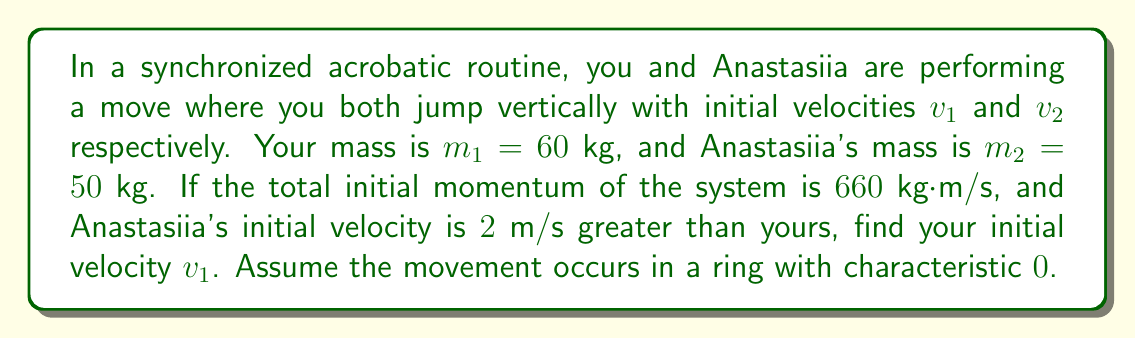Can you answer this question? Let's approach this step-by-step using the principles of momentum conservation and ring theory:

1) In a ring of characteristic 0, we can use standard algebraic operations. The total momentum of the system is given by:

   $$p_{total} = m_1v_1 + m_2v_2 = 660$$

2) We're told that Anastasiia's velocity is 2 m/s greater than yours:

   $$v_2 = v_1 + 2$$

3) Substituting this into the momentum equation:

   $$m_1v_1 + m_2(v_1 + 2) = 660$$

4) Expanding:

   $$60v_1 + 50v_1 + 100 = 660$$

5) Simplifying:

   $$110v_1 + 100 = 660$$

6) Subtracting 100 from both sides:

   $$110v_1 = 560$$

7) Dividing both sides by 110:

   $$v_1 = \frac{560}{110} = \frac{56}{11} = 5.0909...$$

8) In the ring of integers modulo 11 (which has characteristic 11), this would be equivalent to 1. However, since we're working in a ring of characteristic 0, we keep the fractional result.

Therefore, your initial velocity $v_1$ is $\frac{56}{11}$ m/s.
Answer: $v_1 = \frac{56}{11}$ m/s 